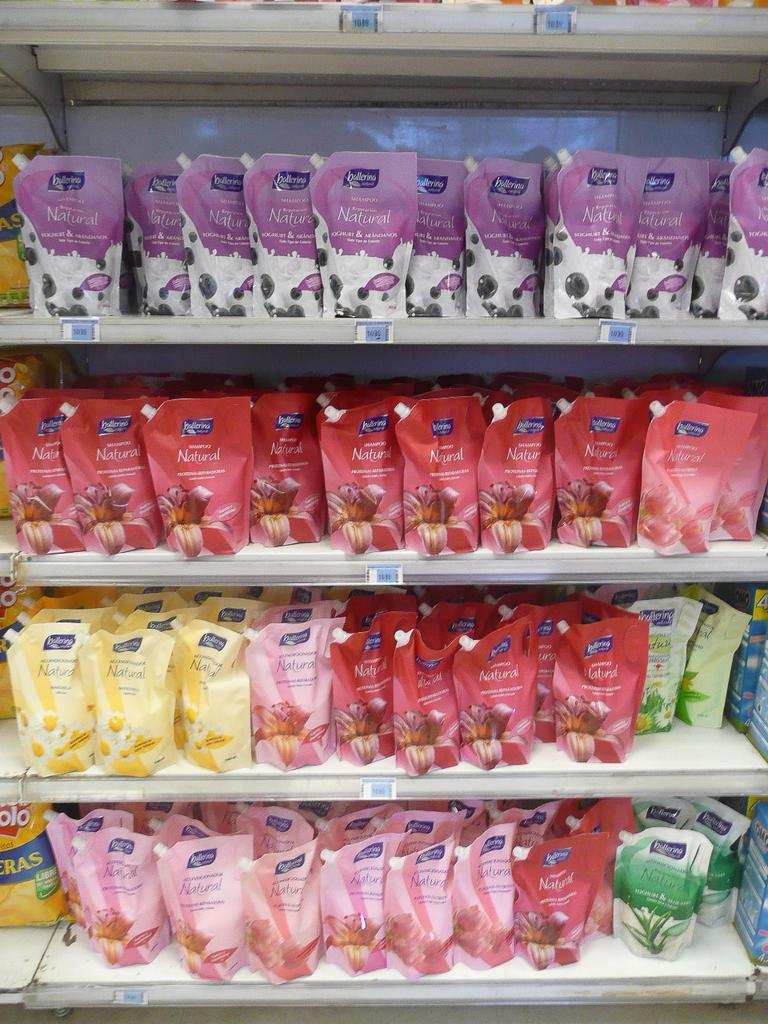<image>
Offer a succinct explanation of the picture presented. many packages with the word ballerina on it 